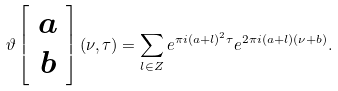<formula> <loc_0><loc_0><loc_500><loc_500>\vartheta \left [ \begin{array} { c } a \\ b \end{array} \right ] ( \nu , \tau ) = \sum _ { l \in { Z } } e ^ { \pi i ( a + l ) ^ { 2 } \tau } e ^ { 2 \pi i ( a + l ) ( \nu + b ) } .</formula> 